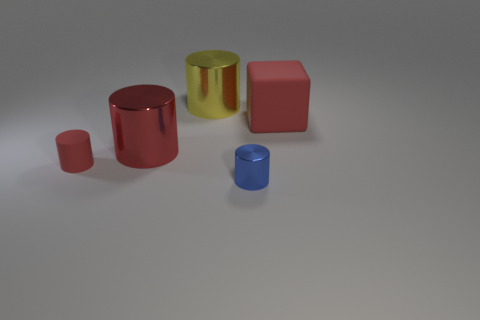How many small cylinders have the same material as the small blue thing?
Offer a terse response. 0. There is a big cylinder in front of the red matte thing that is behind the large metallic cylinder in front of the matte cube; what color is it?
Ensure brevity in your answer.  Red. Is the size of the blue metal object the same as the yellow metallic object?
Provide a succinct answer. No. Is there anything else that is the same shape as the yellow metal thing?
Provide a short and direct response. Yes. What number of things are big red blocks that are behind the blue metallic cylinder or large shiny cylinders?
Your response must be concise. 3. Does the big matte object have the same shape as the small shiny thing?
Provide a short and direct response. No. What number of other things are the same size as the blue thing?
Give a very brief answer. 1. The small metal object is what color?
Offer a terse response. Blue. How many big objects are cylinders or yellow cylinders?
Make the answer very short. 2. Does the rubber thing that is to the left of the cube have the same size as the shiny cylinder on the right side of the yellow thing?
Your answer should be compact. Yes. 